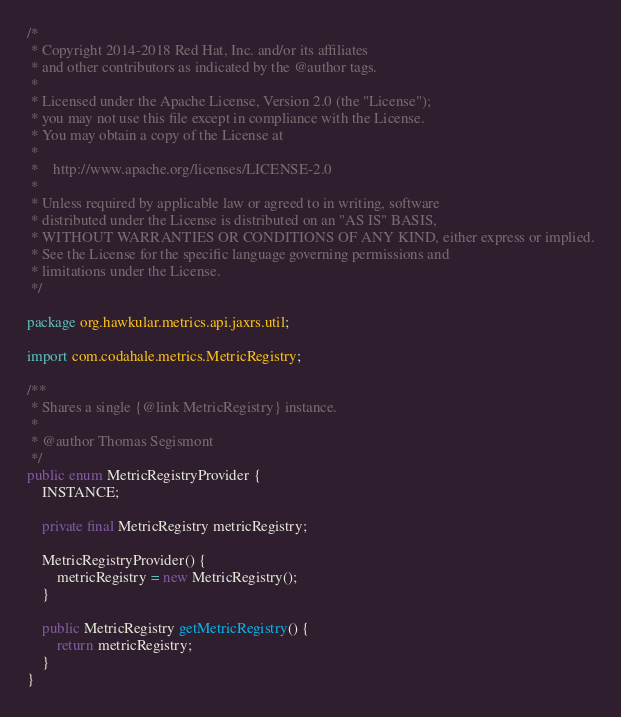<code> <loc_0><loc_0><loc_500><loc_500><_Java_>/*
 * Copyright 2014-2018 Red Hat, Inc. and/or its affiliates
 * and other contributors as indicated by the @author tags.
 *
 * Licensed under the Apache License, Version 2.0 (the "License");
 * you may not use this file except in compliance with the License.
 * You may obtain a copy of the License at
 *
 *    http://www.apache.org/licenses/LICENSE-2.0
 *
 * Unless required by applicable law or agreed to in writing, software
 * distributed under the License is distributed on an "AS IS" BASIS,
 * WITHOUT WARRANTIES OR CONDITIONS OF ANY KIND, either express or implied.
 * See the License for the specific language governing permissions and
 * limitations under the License.
 */

package org.hawkular.metrics.api.jaxrs.util;

import com.codahale.metrics.MetricRegistry;

/**
 * Shares a single {@link MetricRegistry} instance.
 *
 * @author Thomas Segismont
 */
public enum MetricRegistryProvider {
    INSTANCE;

    private final MetricRegistry metricRegistry;

    MetricRegistryProvider() {
        metricRegistry = new MetricRegistry();
    }

    public MetricRegistry getMetricRegistry() {
        return metricRegistry;
    }
}
</code> 